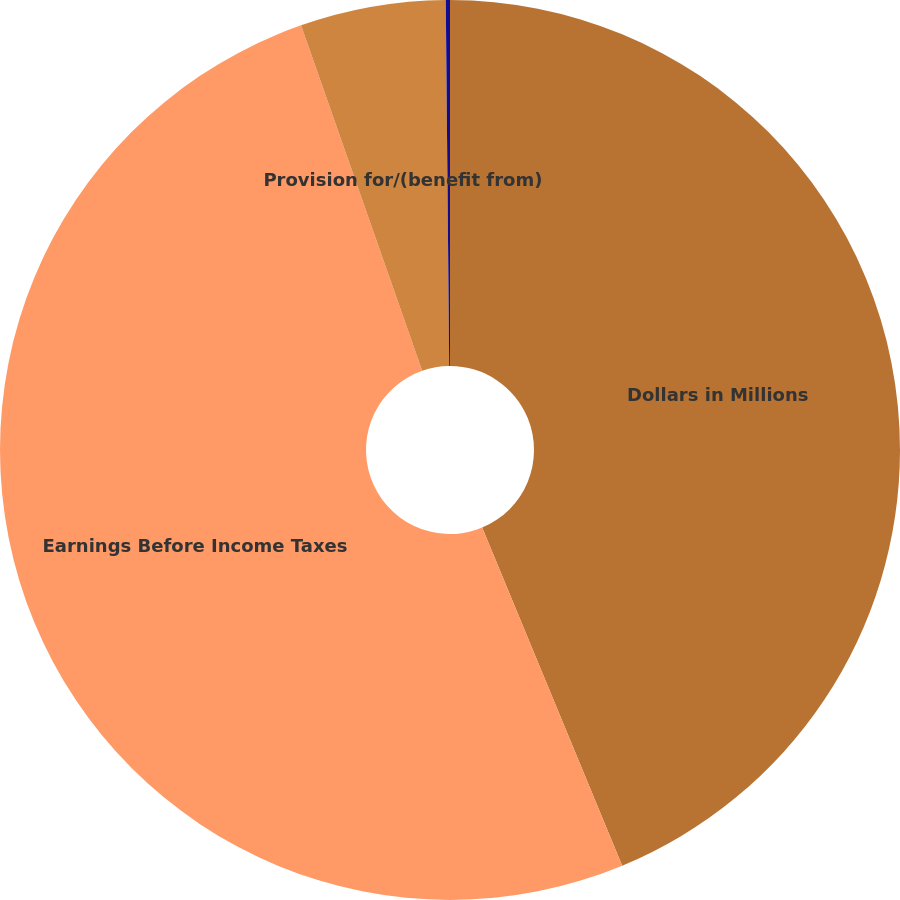<chart> <loc_0><loc_0><loc_500><loc_500><pie_chart><fcel>Dollars in Millions<fcel>Earnings Before Income Taxes<fcel>Provision for/(benefit from)<fcel>Effective tax/(benefit) rate<nl><fcel>43.75%<fcel>50.88%<fcel>5.22%<fcel>0.15%<nl></chart> 